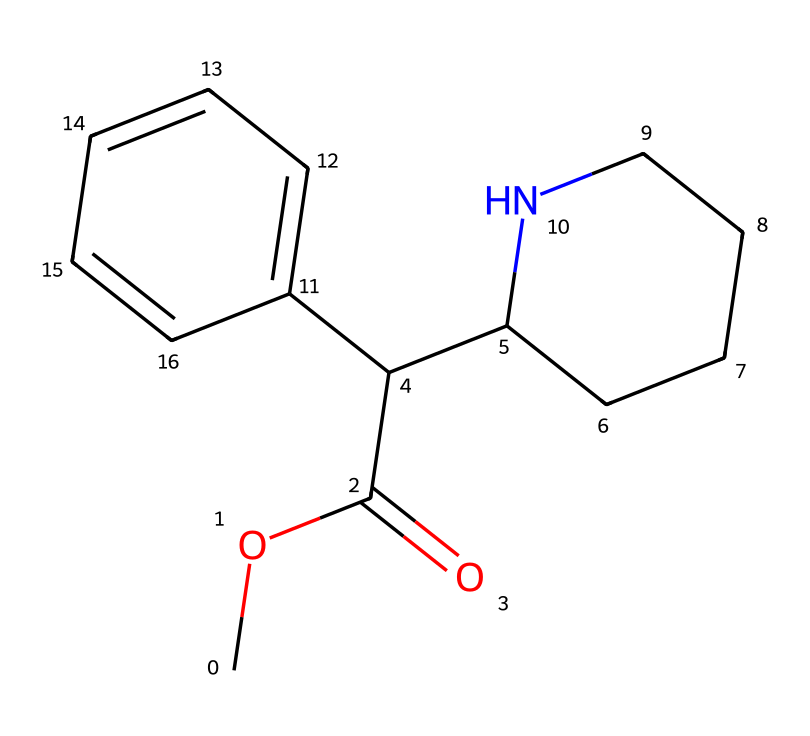What is the formula for methylphenidate? The SMILES representation translates to the molecular formula, which consists of counting carbon (C), hydrogen (H), oxygen (O), and nitrogen (N) atoms present in the structure. From the SMILES, there are 17 carbons, 19 hydrogens, 2 oxygens, and 1 nitrogen, leading to the formula C17H19N2O2.
Answer: C17H19N2O2 How many rings are present in this structure? Analyzing the SMILES notation, we can identify cyclic structures. The 'C1' notations indicate the presence of two ring systems. Therefore, there are two rings in the chemical structure.
Answer: 2 What type of amine is present in methylphenidate? In the structure, there is a nitrogen atom integrated within a cycloalkyl ring (specifically a piperidine ring). This indicates that the amine group is secondary, as it is attached to two carbon atoms.
Answer: secondary What type of functional group does methylphenidate contain? The SMILES structure indicates the presence of a carbonyl group (C=O), specifically as part of an ester group (-COOC-) in the molecule. This functional group gives the drug its characteristics.
Answer: ester What does the presence of the nitrogen atom indicate about methylphenidate's classification? The inclusion of the nitrogen atom in the structure reveals that methylphenidate is classified as an amine. Amines are often pivotal in pharmacological aspects, indicating potential for neurochemical activity.
Answer: amine How many carbon atoms are in the piperidine ring of methylphenidate? By examining the structure of the piperidine ring closely, we can identify that it includes five carbon atoms in its cyclic formation. Therefore, the total count of carbon atoms in the piperidine ring is five.
Answer: 5 